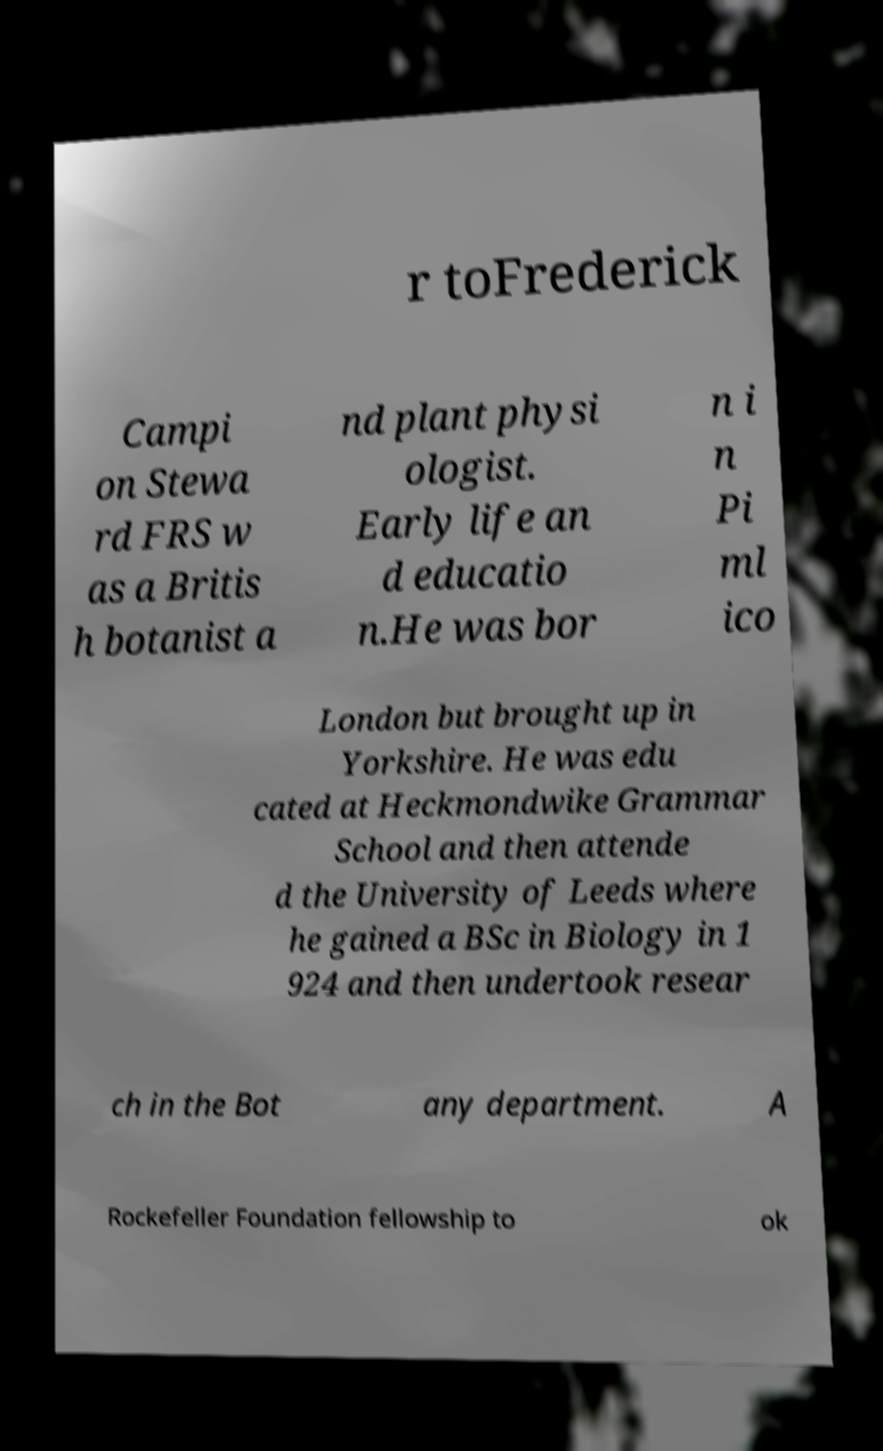Can you read and provide the text displayed in the image?This photo seems to have some interesting text. Can you extract and type it out for me? r toFrederick Campi on Stewa rd FRS w as a Britis h botanist a nd plant physi ologist. Early life an d educatio n.He was bor n i n Pi ml ico London but brought up in Yorkshire. He was edu cated at Heckmondwike Grammar School and then attende d the University of Leeds where he gained a BSc in Biology in 1 924 and then undertook resear ch in the Bot any department. A Rockefeller Foundation fellowship to ok 